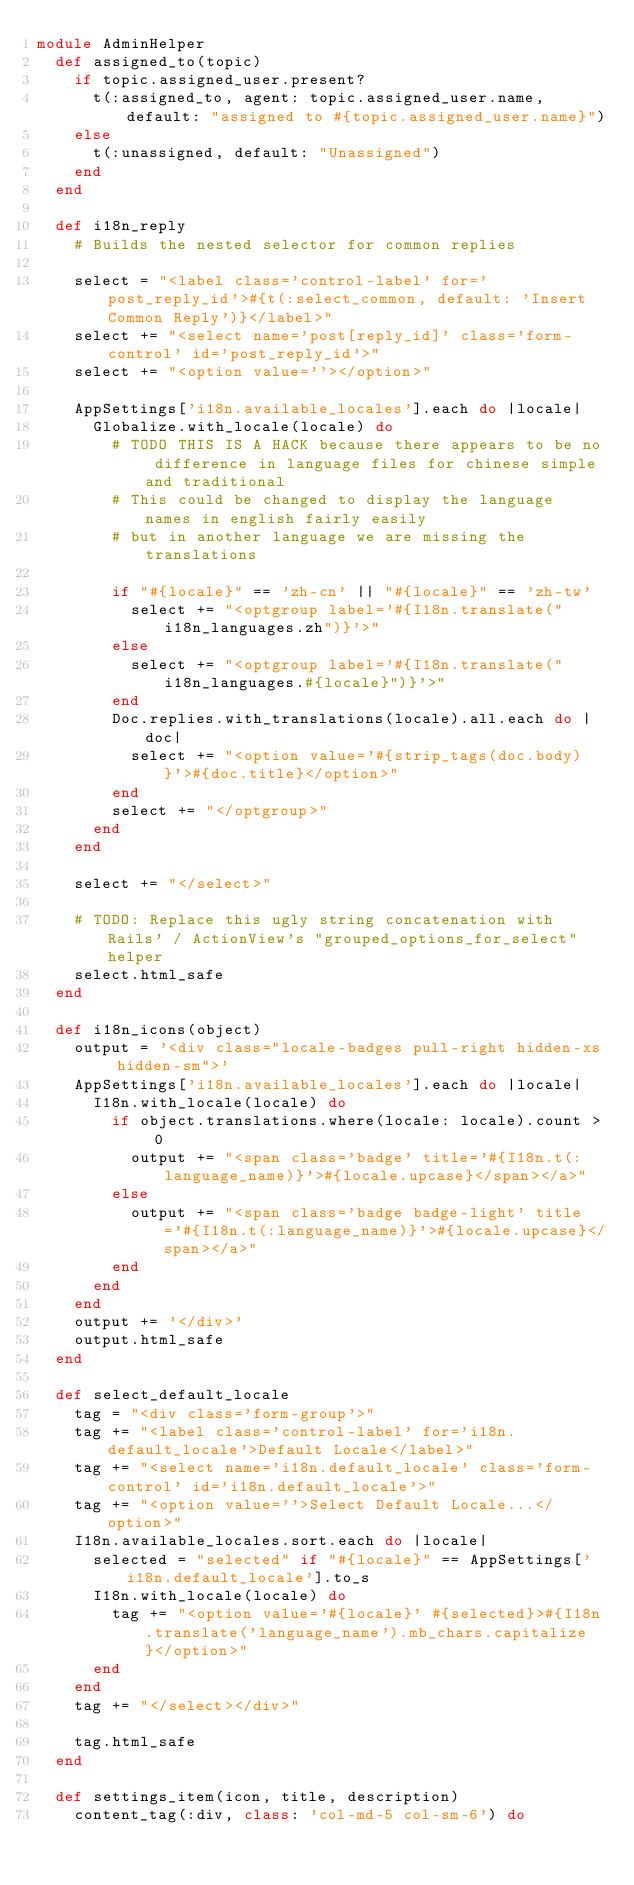<code> <loc_0><loc_0><loc_500><loc_500><_Ruby_>module AdminHelper
  def assigned_to(topic)
    if topic.assigned_user.present?
      t(:assigned_to, agent: topic.assigned_user.name, default: "assigned to #{topic.assigned_user.name}")
    else
      t(:unassigned, default: "Unassigned")
    end
  end

  def i18n_reply
    # Builds the nested selector for common replies

    select = "<label class='control-label' for='post_reply_id'>#{t(:select_common, default: 'Insert Common Reply')}</label>"
    select += "<select name='post[reply_id]' class='form-control' id='post_reply_id'>"
    select += "<option value=''></option>"

    AppSettings['i18n.available_locales'].each do |locale|
      Globalize.with_locale(locale) do
        # TODO THIS IS A HACK because there appears to be no difference in language files for chinese simple and traditional
        # This could be changed to display the language names in english fairly easily
        # but in another language we are missing the translations

        if "#{locale}" == 'zh-cn' || "#{locale}" == 'zh-tw'
          select += "<optgroup label='#{I18n.translate("i18n_languages.zh")}'>"
        else
          select += "<optgroup label='#{I18n.translate("i18n_languages.#{locale}")}'>"
        end
        Doc.replies.with_translations(locale).all.each do |doc|
          select += "<option value='#{strip_tags(doc.body)}'>#{doc.title}</option>"
        end
        select += "</optgroup>"
      end
    end

    select += "</select>"

    # TODO: Replace this ugly string concatenation with Rails' / ActionView's "grouped_options_for_select" helper
    select.html_safe
  end

  def i18n_icons(object)
    output = '<div class="locale-badges pull-right hidden-xs hidden-sm">'
    AppSettings['i18n.available_locales'].each do |locale|
      I18n.with_locale(locale) do
        if object.translations.where(locale: locale).count > 0
          output += "<span class='badge' title='#{I18n.t(:language_name)}'>#{locale.upcase}</span></a>"
        else
          output += "<span class='badge badge-light' title='#{I18n.t(:language_name)}'>#{locale.upcase}</span></a>"
        end
      end
    end
    output += '</div>'
    output.html_safe
  end

  def select_default_locale
    tag = "<div class='form-group'>"
    tag += "<label class='control-label' for='i18n.default_locale'>Default Locale</label>"
    tag += "<select name='i18n.default_locale' class='form-control' id='i18n.default_locale'>"
    tag += "<option value=''>Select Default Locale...</option>"
    I18n.available_locales.sort.each do |locale|
      selected = "selected" if "#{locale}" == AppSettings['i18n.default_locale'].to_s
      I18n.with_locale(locale) do
        tag += "<option value='#{locale}' #{selected}>#{I18n.translate('language_name').mb_chars.capitalize}</option>"
      end
    end
    tag += "</select></div>"

    tag.html_safe
  end

  def settings_item(icon, title, description)
    content_tag(:div, class: 'col-md-5 col-sm-6') do</code> 